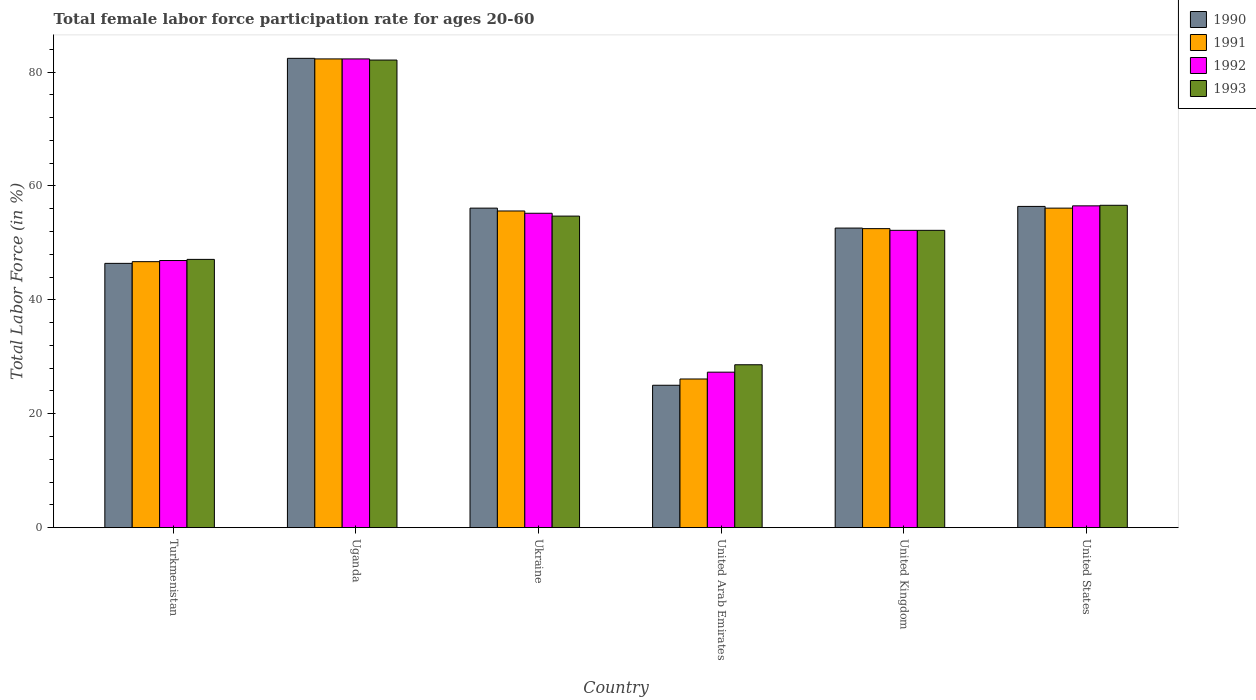How many groups of bars are there?
Give a very brief answer. 6. How many bars are there on the 3rd tick from the left?
Keep it short and to the point. 4. What is the label of the 1st group of bars from the left?
Provide a succinct answer. Turkmenistan. In how many cases, is the number of bars for a given country not equal to the number of legend labels?
Provide a succinct answer. 0. What is the female labor force participation rate in 1990 in Turkmenistan?
Ensure brevity in your answer.  46.4. Across all countries, what is the maximum female labor force participation rate in 1991?
Make the answer very short. 82.3. Across all countries, what is the minimum female labor force participation rate in 1991?
Make the answer very short. 26.1. In which country was the female labor force participation rate in 1992 maximum?
Your response must be concise. Uganda. In which country was the female labor force participation rate in 1992 minimum?
Your answer should be very brief. United Arab Emirates. What is the total female labor force participation rate in 1993 in the graph?
Make the answer very short. 321.3. What is the difference between the female labor force participation rate in 1991 in Ukraine and that in United Kingdom?
Your answer should be compact. 3.1. What is the difference between the female labor force participation rate in 1990 in United Kingdom and the female labor force participation rate in 1991 in United Arab Emirates?
Your answer should be compact. 26.5. What is the average female labor force participation rate in 1993 per country?
Make the answer very short. 53.55. What is the difference between the female labor force participation rate of/in 1991 and female labor force participation rate of/in 1992 in United States?
Provide a succinct answer. -0.4. In how many countries, is the female labor force participation rate in 1990 greater than 56 %?
Make the answer very short. 3. What is the ratio of the female labor force participation rate in 1992 in Ukraine to that in United Arab Emirates?
Offer a very short reply. 2.02. Is the female labor force participation rate in 1990 in United Kingdom less than that in United States?
Ensure brevity in your answer.  Yes. What is the difference between the highest and the second highest female labor force participation rate in 1992?
Offer a terse response. -25.8. What is the difference between the highest and the lowest female labor force participation rate in 1990?
Keep it short and to the point. 57.4. Is the sum of the female labor force participation rate in 1990 in Ukraine and United States greater than the maximum female labor force participation rate in 1991 across all countries?
Provide a succinct answer. Yes. Is it the case that in every country, the sum of the female labor force participation rate in 1990 and female labor force participation rate in 1993 is greater than the sum of female labor force participation rate in 1991 and female labor force participation rate in 1992?
Your response must be concise. No. What is the title of the graph?
Make the answer very short. Total female labor force participation rate for ages 20-60. Does "1973" appear as one of the legend labels in the graph?
Your answer should be compact. No. What is the label or title of the X-axis?
Your answer should be compact. Country. What is the Total Labor Force (in %) of 1990 in Turkmenistan?
Your response must be concise. 46.4. What is the Total Labor Force (in %) of 1991 in Turkmenistan?
Your response must be concise. 46.7. What is the Total Labor Force (in %) of 1992 in Turkmenistan?
Give a very brief answer. 46.9. What is the Total Labor Force (in %) in 1993 in Turkmenistan?
Your response must be concise. 47.1. What is the Total Labor Force (in %) of 1990 in Uganda?
Make the answer very short. 82.4. What is the Total Labor Force (in %) of 1991 in Uganda?
Make the answer very short. 82.3. What is the Total Labor Force (in %) in 1992 in Uganda?
Your response must be concise. 82.3. What is the Total Labor Force (in %) in 1993 in Uganda?
Your answer should be compact. 82.1. What is the Total Labor Force (in %) in 1990 in Ukraine?
Make the answer very short. 56.1. What is the Total Labor Force (in %) in 1991 in Ukraine?
Keep it short and to the point. 55.6. What is the Total Labor Force (in %) in 1992 in Ukraine?
Offer a terse response. 55.2. What is the Total Labor Force (in %) of 1993 in Ukraine?
Ensure brevity in your answer.  54.7. What is the Total Labor Force (in %) in 1991 in United Arab Emirates?
Ensure brevity in your answer.  26.1. What is the Total Labor Force (in %) of 1992 in United Arab Emirates?
Ensure brevity in your answer.  27.3. What is the Total Labor Force (in %) in 1993 in United Arab Emirates?
Provide a short and direct response. 28.6. What is the Total Labor Force (in %) in 1990 in United Kingdom?
Your response must be concise. 52.6. What is the Total Labor Force (in %) of 1991 in United Kingdom?
Ensure brevity in your answer.  52.5. What is the Total Labor Force (in %) in 1992 in United Kingdom?
Make the answer very short. 52.2. What is the Total Labor Force (in %) in 1993 in United Kingdom?
Provide a short and direct response. 52.2. What is the Total Labor Force (in %) of 1990 in United States?
Offer a terse response. 56.4. What is the Total Labor Force (in %) in 1991 in United States?
Provide a succinct answer. 56.1. What is the Total Labor Force (in %) of 1992 in United States?
Your answer should be very brief. 56.5. What is the Total Labor Force (in %) of 1993 in United States?
Ensure brevity in your answer.  56.6. Across all countries, what is the maximum Total Labor Force (in %) of 1990?
Provide a short and direct response. 82.4. Across all countries, what is the maximum Total Labor Force (in %) in 1991?
Ensure brevity in your answer.  82.3. Across all countries, what is the maximum Total Labor Force (in %) of 1992?
Provide a succinct answer. 82.3. Across all countries, what is the maximum Total Labor Force (in %) in 1993?
Provide a short and direct response. 82.1. Across all countries, what is the minimum Total Labor Force (in %) in 1990?
Your answer should be compact. 25. Across all countries, what is the minimum Total Labor Force (in %) in 1991?
Offer a terse response. 26.1. Across all countries, what is the minimum Total Labor Force (in %) in 1992?
Your response must be concise. 27.3. Across all countries, what is the minimum Total Labor Force (in %) of 1993?
Ensure brevity in your answer.  28.6. What is the total Total Labor Force (in %) of 1990 in the graph?
Offer a very short reply. 318.9. What is the total Total Labor Force (in %) in 1991 in the graph?
Your answer should be compact. 319.3. What is the total Total Labor Force (in %) of 1992 in the graph?
Keep it short and to the point. 320.4. What is the total Total Labor Force (in %) of 1993 in the graph?
Your answer should be compact. 321.3. What is the difference between the Total Labor Force (in %) in 1990 in Turkmenistan and that in Uganda?
Offer a terse response. -36. What is the difference between the Total Labor Force (in %) in 1991 in Turkmenistan and that in Uganda?
Your answer should be very brief. -35.6. What is the difference between the Total Labor Force (in %) in 1992 in Turkmenistan and that in Uganda?
Keep it short and to the point. -35.4. What is the difference between the Total Labor Force (in %) in 1993 in Turkmenistan and that in Uganda?
Ensure brevity in your answer.  -35. What is the difference between the Total Labor Force (in %) of 1991 in Turkmenistan and that in Ukraine?
Provide a succinct answer. -8.9. What is the difference between the Total Labor Force (in %) of 1993 in Turkmenistan and that in Ukraine?
Provide a short and direct response. -7.6. What is the difference between the Total Labor Force (in %) in 1990 in Turkmenistan and that in United Arab Emirates?
Offer a very short reply. 21.4. What is the difference between the Total Labor Force (in %) of 1991 in Turkmenistan and that in United Arab Emirates?
Keep it short and to the point. 20.6. What is the difference between the Total Labor Force (in %) in 1992 in Turkmenistan and that in United Arab Emirates?
Provide a succinct answer. 19.6. What is the difference between the Total Labor Force (in %) in 1993 in Turkmenistan and that in United Arab Emirates?
Your answer should be very brief. 18.5. What is the difference between the Total Labor Force (in %) of 1990 in Turkmenistan and that in United Kingdom?
Make the answer very short. -6.2. What is the difference between the Total Labor Force (in %) in 1991 in Turkmenistan and that in United Kingdom?
Your answer should be very brief. -5.8. What is the difference between the Total Labor Force (in %) of 1992 in Turkmenistan and that in United Kingdom?
Offer a very short reply. -5.3. What is the difference between the Total Labor Force (in %) in 1993 in Turkmenistan and that in United Kingdom?
Keep it short and to the point. -5.1. What is the difference between the Total Labor Force (in %) in 1991 in Turkmenistan and that in United States?
Provide a short and direct response. -9.4. What is the difference between the Total Labor Force (in %) in 1990 in Uganda and that in Ukraine?
Your answer should be compact. 26.3. What is the difference between the Total Labor Force (in %) of 1991 in Uganda and that in Ukraine?
Your response must be concise. 26.7. What is the difference between the Total Labor Force (in %) in 1992 in Uganda and that in Ukraine?
Provide a short and direct response. 27.1. What is the difference between the Total Labor Force (in %) in 1993 in Uganda and that in Ukraine?
Offer a terse response. 27.4. What is the difference between the Total Labor Force (in %) of 1990 in Uganda and that in United Arab Emirates?
Keep it short and to the point. 57.4. What is the difference between the Total Labor Force (in %) in 1991 in Uganda and that in United Arab Emirates?
Provide a succinct answer. 56.2. What is the difference between the Total Labor Force (in %) in 1992 in Uganda and that in United Arab Emirates?
Your answer should be compact. 55. What is the difference between the Total Labor Force (in %) in 1993 in Uganda and that in United Arab Emirates?
Offer a very short reply. 53.5. What is the difference between the Total Labor Force (in %) of 1990 in Uganda and that in United Kingdom?
Keep it short and to the point. 29.8. What is the difference between the Total Labor Force (in %) in 1991 in Uganda and that in United Kingdom?
Ensure brevity in your answer.  29.8. What is the difference between the Total Labor Force (in %) in 1992 in Uganda and that in United Kingdom?
Make the answer very short. 30.1. What is the difference between the Total Labor Force (in %) of 1993 in Uganda and that in United Kingdom?
Give a very brief answer. 29.9. What is the difference between the Total Labor Force (in %) in 1991 in Uganda and that in United States?
Offer a terse response. 26.2. What is the difference between the Total Labor Force (in %) of 1992 in Uganda and that in United States?
Make the answer very short. 25.8. What is the difference between the Total Labor Force (in %) in 1990 in Ukraine and that in United Arab Emirates?
Offer a terse response. 31.1. What is the difference between the Total Labor Force (in %) in 1991 in Ukraine and that in United Arab Emirates?
Your response must be concise. 29.5. What is the difference between the Total Labor Force (in %) in 1992 in Ukraine and that in United Arab Emirates?
Provide a succinct answer. 27.9. What is the difference between the Total Labor Force (in %) of 1993 in Ukraine and that in United Arab Emirates?
Offer a terse response. 26.1. What is the difference between the Total Labor Force (in %) in 1990 in Ukraine and that in United Kingdom?
Make the answer very short. 3.5. What is the difference between the Total Labor Force (in %) in 1991 in Ukraine and that in United Kingdom?
Offer a very short reply. 3.1. What is the difference between the Total Labor Force (in %) in 1992 in Ukraine and that in United Kingdom?
Give a very brief answer. 3. What is the difference between the Total Labor Force (in %) of 1992 in Ukraine and that in United States?
Offer a very short reply. -1.3. What is the difference between the Total Labor Force (in %) in 1993 in Ukraine and that in United States?
Keep it short and to the point. -1.9. What is the difference between the Total Labor Force (in %) in 1990 in United Arab Emirates and that in United Kingdom?
Provide a succinct answer. -27.6. What is the difference between the Total Labor Force (in %) of 1991 in United Arab Emirates and that in United Kingdom?
Your response must be concise. -26.4. What is the difference between the Total Labor Force (in %) of 1992 in United Arab Emirates and that in United Kingdom?
Give a very brief answer. -24.9. What is the difference between the Total Labor Force (in %) of 1993 in United Arab Emirates and that in United Kingdom?
Offer a very short reply. -23.6. What is the difference between the Total Labor Force (in %) of 1990 in United Arab Emirates and that in United States?
Offer a terse response. -31.4. What is the difference between the Total Labor Force (in %) in 1991 in United Arab Emirates and that in United States?
Offer a very short reply. -30. What is the difference between the Total Labor Force (in %) in 1992 in United Arab Emirates and that in United States?
Provide a short and direct response. -29.2. What is the difference between the Total Labor Force (in %) of 1990 in United Kingdom and that in United States?
Provide a short and direct response. -3.8. What is the difference between the Total Labor Force (in %) in 1992 in United Kingdom and that in United States?
Your response must be concise. -4.3. What is the difference between the Total Labor Force (in %) of 1993 in United Kingdom and that in United States?
Make the answer very short. -4.4. What is the difference between the Total Labor Force (in %) in 1990 in Turkmenistan and the Total Labor Force (in %) in 1991 in Uganda?
Provide a succinct answer. -35.9. What is the difference between the Total Labor Force (in %) in 1990 in Turkmenistan and the Total Labor Force (in %) in 1992 in Uganda?
Your answer should be very brief. -35.9. What is the difference between the Total Labor Force (in %) of 1990 in Turkmenistan and the Total Labor Force (in %) of 1993 in Uganda?
Your answer should be very brief. -35.7. What is the difference between the Total Labor Force (in %) in 1991 in Turkmenistan and the Total Labor Force (in %) in 1992 in Uganda?
Offer a terse response. -35.6. What is the difference between the Total Labor Force (in %) of 1991 in Turkmenistan and the Total Labor Force (in %) of 1993 in Uganda?
Ensure brevity in your answer.  -35.4. What is the difference between the Total Labor Force (in %) of 1992 in Turkmenistan and the Total Labor Force (in %) of 1993 in Uganda?
Offer a very short reply. -35.2. What is the difference between the Total Labor Force (in %) in 1990 in Turkmenistan and the Total Labor Force (in %) in 1991 in Ukraine?
Your response must be concise. -9.2. What is the difference between the Total Labor Force (in %) in 1990 in Turkmenistan and the Total Labor Force (in %) in 1993 in Ukraine?
Provide a short and direct response. -8.3. What is the difference between the Total Labor Force (in %) of 1991 in Turkmenistan and the Total Labor Force (in %) of 1992 in Ukraine?
Your response must be concise. -8.5. What is the difference between the Total Labor Force (in %) in 1991 in Turkmenistan and the Total Labor Force (in %) in 1993 in Ukraine?
Provide a short and direct response. -8. What is the difference between the Total Labor Force (in %) of 1992 in Turkmenistan and the Total Labor Force (in %) of 1993 in Ukraine?
Provide a succinct answer. -7.8. What is the difference between the Total Labor Force (in %) in 1990 in Turkmenistan and the Total Labor Force (in %) in 1991 in United Arab Emirates?
Make the answer very short. 20.3. What is the difference between the Total Labor Force (in %) in 1990 in Turkmenistan and the Total Labor Force (in %) in 1992 in United Arab Emirates?
Ensure brevity in your answer.  19.1. What is the difference between the Total Labor Force (in %) of 1992 in Turkmenistan and the Total Labor Force (in %) of 1993 in United Arab Emirates?
Ensure brevity in your answer.  18.3. What is the difference between the Total Labor Force (in %) in 1990 in Turkmenistan and the Total Labor Force (in %) in 1993 in United Kingdom?
Give a very brief answer. -5.8. What is the difference between the Total Labor Force (in %) in 1991 in Turkmenistan and the Total Labor Force (in %) in 1992 in United Kingdom?
Offer a very short reply. -5.5. What is the difference between the Total Labor Force (in %) in 1990 in Turkmenistan and the Total Labor Force (in %) in 1991 in United States?
Provide a succinct answer. -9.7. What is the difference between the Total Labor Force (in %) in 1990 in Turkmenistan and the Total Labor Force (in %) in 1992 in United States?
Ensure brevity in your answer.  -10.1. What is the difference between the Total Labor Force (in %) of 1990 in Turkmenistan and the Total Labor Force (in %) of 1993 in United States?
Ensure brevity in your answer.  -10.2. What is the difference between the Total Labor Force (in %) of 1991 in Turkmenistan and the Total Labor Force (in %) of 1992 in United States?
Offer a terse response. -9.8. What is the difference between the Total Labor Force (in %) of 1991 in Turkmenistan and the Total Labor Force (in %) of 1993 in United States?
Provide a short and direct response. -9.9. What is the difference between the Total Labor Force (in %) in 1992 in Turkmenistan and the Total Labor Force (in %) in 1993 in United States?
Your answer should be very brief. -9.7. What is the difference between the Total Labor Force (in %) in 1990 in Uganda and the Total Labor Force (in %) in 1991 in Ukraine?
Give a very brief answer. 26.8. What is the difference between the Total Labor Force (in %) of 1990 in Uganda and the Total Labor Force (in %) of 1992 in Ukraine?
Your answer should be compact. 27.2. What is the difference between the Total Labor Force (in %) of 1990 in Uganda and the Total Labor Force (in %) of 1993 in Ukraine?
Offer a terse response. 27.7. What is the difference between the Total Labor Force (in %) in 1991 in Uganda and the Total Labor Force (in %) in 1992 in Ukraine?
Ensure brevity in your answer.  27.1. What is the difference between the Total Labor Force (in %) of 1991 in Uganda and the Total Labor Force (in %) of 1993 in Ukraine?
Your answer should be very brief. 27.6. What is the difference between the Total Labor Force (in %) in 1992 in Uganda and the Total Labor Force (in %) in 1993 in Ukraine?
Keep it short and to the point. 27.6. What is the difference between the Total Labor Force (in %) of 1990 in Uganda and the Total Labor Force (in %) of 1991 in United Arab Emirates?
Provide a short and direct response. 56.3. What is the difference between the Total Labor Force (in %) of 1990 in Uganda and the Total Labor Force (in %) of 1992 in United Arab Emirates?
Provide a succinct answer. 55.1. What is the difference between the Total Labor Force (in %) in 1990 in Uganda and the Total Labor Force (in %) in 1993 in United Arab Emirates?
Make the answer very short. 53.8. What is the difference between the Total Labor Force (in %) in 1991 in Uganda and the Total Labor Force (in %) in 1992 in United Arab Emirates?
Ensure brevity in your answer.  55. What is the difference between the Total Labor Force (in %) in 1991 in Uganda and the Total Labor Force (in %) in 1993 in United Arab Emirates?
Offer a very short reply. 53.7. What is the difference between the Total Labor Force (in %) in 1992 in Uganda and the Total Labor Force (in %) in 1993 in United Arab Emirates?
Make the answer very short. 53.7. What is the difference between the Total Labor Force (in %) of 1990 in Uganda and the Total Labor Force (in %) of 1991 in United Kingdom?
Offer a very short reply. 29.9. What is the difference between the Total Labor Force (in %) of 1990 in Uganda and the Total Labor Force (in %) of 1992 in United Kingdom?
Your response must be concise. 30.2. What is the difference between the Total Labor Force (in %) in 1990 in Uganda and the Total Labor Force (in %) in 1993 in United Kingdom?
Your response must be concise. 30.2. What is the difference between the Total Labor Force (in %) of 1991 in Uganda and the Total Labor Force (in %) of 1992 in United Kingdom?
Offer a very short reply. 30.1. What is the difference between the Total Labor Force (in %) of 1991 in Uganda and the Total Labor Force (in %) of 1993 in United Kingdom?
Keep it short and to the point. 30.1. What is the difference between the Total Labor Force (in %) of 1992 in Uganda and the Total Labor Force (in %) of 1993 in United Kingdom?
Your response must be concise. 30.1. What is the difference between the Total Labor Force (in %) in 1990 in Uganda and the Total Labor Force (in %) in 1991 in United States?
Your response must be concise. 26.3. What is the difference between the Total Labor Force (in %) in 1990 in Uganda and the Total Labor Force (in %) in 1992 in United States?
Offer a very short reply. 25.9. What is the difference between the Total Labor Force (in %) in 1990 in Uganda and the Total Labor Force (in %) in 1993 in United States?
Make the answer very short. 25.8. What is the difference between the Total Labor Force (in %) in 1991 in Uganda and the Total Labor Force (in %) in 1992 in United States?
Provide a short and direct response. 25.8. What is the difference between the Total Labor Force (in %) of 1991 in Uganda and the Total Labor Force (in %) of 1993 in United States?
Your response must be concise. 25.7. What is the difference between the Total Labor Force (in %) in 1992 in Uganda and the Total Labor Force (in %) in 1993 in United States?
Make the answer very short. 25.7. What is the difference between the Total Labor Force (in %) of 1990 in Ukraine and the Total Labor Force (in %) of 1992 in United Arab Emirates?
Your response must be concise. 28.8. What is the difference between the Total Labor Force (in %) in 1990 in Ukraine and the Total Labor Force (in %) in 1993 in United Arab Emirates?
Ensure brevity in your answer.  27.5. What is the difference between the Total Labor Force (in %) in 1991 in Ukraine and the Total Labor Force (in %) in 1992 in United Arab Emirates?
Your response must be concise. 28.3. What is the difference between the Total Labor Force (in %) in 1992 in Ukraine and the Total Labor Force (in %) in 1993 in United Arab Emirates?
Your response must be concise. 26.6. What is the difference between the Total Labor Force (in %) of 1991 in Ukraine and the Total Labor Force (in %) of 1993 in United Kingdom?
Provide a succinct answer. 3.4. What is the difference between the Total Labor Force (in %) of 1992 in Ukraine and the Total Labor Force (in %) of 1993 in United Kingdom?
Make the answer very short. 3. What is the difference between the Total Labor Force (in %) of 1990 in Ukraine and the Total Labor Force (in %) of 1991 in United States?
Offer a very short reply. 0. What is the difference between the Total Labor Force (in %) in 1990 in Ukraine and the Total Labor Force (in %) in 1993 in United States?
Keep it short and to the point. -0.5. What is the difference between the Total Labor Force (in %) of 1991 in Ukraine and the Total Labor Force (in %) of 1992 in United States?
Give a very brief answer. -0.9. What is the difference between the Total Labor Force (in %) of 1990 in United Arab Emirates and the Total Labor Force (in %) of 1991 in United Kingdom?
Keep it short and to the point. -27.5. What is the difference between the Total Labor Force (in %) of 1990 in United Arab Emirates and the Total Labor Force (in %) of 1992 in United Kingdom?
Offer a terse response. -27.2. What is the difference between the Total Labor Force (in %) in 1990 in United Arab Emirates and the Total Labor Force (in %) in 1993 in United Kingdom?
Your response must be concise. -27.2. What is the difference between the Total Labor Force (in %) in 1991 in United Arab Emirates and the Total Labor Force (in %) in 1992 in United Kingdom?
Your answer should be very brief. -26.1. What is the difference between the Total Labor Force (in %) in 1991 in United Arab Emirates and the Total Labor Force (in %) in 1993 in United Kingdom?
Make the answer very short. -26.1. What is the difference between the Total Labor Force (in %) of 1992 in United Arab Emirates and the Total Labor Force (in %) of 1993 in United Kingdom?
Offer a very short reply. -24.9. What is the difference between the Total Labor Force (in %) in 1990 in United Arab Emirates and the Total Labor Force (in %) in 1991 in United States?
Make the answer very short. -31.1. What is the difference between the Total Labor Force (in %) in 1990 in United Arab Emirates and the Total Labor Force (in %) in 1992 in United States?
Provide a short and direct response. -31.5. What is the difference between the Total Labor Force (in %) in 1990 in United Arab Emirates and the Total Labor Force (in %) in 1993 in United States?
Ensure brevity in your answer.  -31.6. What is the difference between the Total Labor Force (in %) in 1991 in United Arab Emirates and the Total Labor Force (in %) in 1992 in United States?
Your answer should be compact. -30.4. What is the difference between the Total Labor Force (in %) of 1991 in United Arab Emirates and the Total Labor Force (in %) of 1993 in United States?
Your answer should be very brief. -30.5. What is the difference between the Total Labor Force (in %) in 1992 in United Arab Emirates and the Total Labor Force (in %) in 1993 in United States?
Make the answer very short. -29.3. What is the difference between the Total Labor Force (in %) in 1990 in United Kingdom and the Total Labor Force (in %) in 1991 in United States?
Provide a succinct answer. -3.5. What is the average Total Labor Force (in %) in 1990 per country?
Offer a very short reply. 53.15. What is the average Total Labor Force (in %) in 1991 per country?
Your answer should be very brief. 53.22. What is the average Total Labor Force (in %) of 1992 per country?
Provide a succinct answer. 53.4. What is the average Total Labor Force (in %) of 1993 per country?
Your answer should be very brief. 53.55. What is the difference between the Total Labor Force (in %) of 1990 and Total Labor Force (in %) of 1993 in Turkmenistan?
Keep it short and to the point. -0.7. What is the difference between the Total Labor Force (in %) in 1991 and Total Labor Force (in %) in 1992 in Turkmenistan?
Ensure brevity in your answer.  -0.2. What is the difference between the Total Labor Force (in %) of 1990 and Total Labor Force (in %) of 1991 in Uganda?
Provide a succinct answer. 0.1. What is the difference between the Total Labor Force (in %) of 1990 and Total Labor Force (in %) of 1992 in Uganda?
Offer a terse response. 0.1. What is the difference between the Total Labor Force (in %) of 1990 and Total Labor Force (in %) of 1993 in Uganda?
Provide a short and direct response. 0.3. What is the difference between the Total Labor Force (in %) in 1991 and Total Labor Force (in %) in 1992 in Uganda?
Provide a succinct answer. 0. What is the difference between the Total Labor Force (in %) of 1990 and Total Labor Force (in %) of 1991 in Ukraine?
Offer a very short reply. 0.5. What is the difference between the Total Labor Force (in %) of 1990 and Total Labor Force (in %) of 1992 in Ukraine?
Ensure brevity in your answer.  0.9. What is the difference between the Total Labor Force (in %) of 1990 and Total Labor Force (in %) of 1993 in Ukraine?
Offer a terse response. 1.4. What is the difference between the Total Labor Force (in %) of 1991 and Total Labor Force (in %) of 1992 in Ukraine?
Keep it short and to the point. 0.4. What is the difference between the Total Labor Force (in %) of 1990 and Total Labor Force (in %) of 1991 in United Arab Emirates?
Give a very brief answer. -1.1. What is the difference between the Total Labor Force (in %) of 1990 and Total Labor Force (in %) of 1993 in United Arab Emirates?
Offer a terse response. -3.6. What is the difference between the Total Labor Force (in %) of 1991 and Total Labor Force (in %) of 1992 in United Arab Emirates?
Offer a very short reply. -1.2. What is the difference between the Total Labor Force (in %) in 1992 and Total Labor Force (in %) in 1993 in United Arab Emirates?
Offer a terse response. -1.3. What is the difference between the Total Labor Force (in %) in 1990 and Total Labor Force (in %) in 1992 in United Kingdom?
Offer a very short reply. 0.4. What is the difference between the Total Labor Force (in %) in 1990 and Total Labor Force (in %) in 1992 in United States?
Provide a succinct answer. -0.1. What is the difference between the Total Labor Force (in %) in 1991 and Total Labor Force (in %) in 1993 in United States?
Keep it short and to the point. -0.5. What is the difference between the Total Labor Force (in %) in 1992 and Total Labor Force (in %) in 1993 in United States?
Your answer should be very brief. -0.1. What is the ratio of the Total Labor Force (in %) in 1990 in Turkmenistan to that in Uganda?
Provide a short and direct response. 0.56. What is the ratio of the Total Labor Force (in %) of 1991 in Turkmenistan to that in Uganda?
Make the answer very short. 0.57. What is the ratio of the Total Labor Force (in %) of 1992 in Turkmenistan to that in Uganda?
Provide a short and direct response. 0.57. What is the ratio of the Total Labor Force (in %) of 1993 in Turkmenistan to that in Uganda?
Offer a very short reply. 0.57. What is the ratio of the Total Labor Force (in %) of 1990 in Turkmenistan to that in Ukraine?
Offer a terse response. 0.83. What is the ratio of the Total Labor Force (in %) in 1991 in Turkmenistan to that in Ukraine?
Provide a short and direct response. 0.84. What is the ratio of the Total Labor Force (in %) of 1992 in Turkmenistan to that in Ukraine?
Provide a short and direct response. 0.85. What is the ratio of the Total Labor Force (in %) of 1993 in Turkmenistan to that in Ukraine?
Your response must be concise. 0.86. What is the ratio of the Total Labor Force (in %) in 1990 in Turkmenistan to that in United Arab Emirates?
Make the answer very short. 1.86. What is the ratio of the Total Labor Force (in %) of 1991 in Turkmenistan to that in United Arab Emirates?
Provide a short and direct response. 1.79. What is the ratio of the Total Labor Force (in %) in 1992 in Turkmenistan to that in United Arab Emirates?
Make the answer very short. 1.72. What is the ratio of the Total Labor Force (in %) in 1993 in Turkmenistan to that in United Arab Emirates?
Give a very brief answer. 1.65. What is the ratio of the Total Labor Force (in %) in 1990 in Turkmenistan to that in United Kingdom?
Your response must be concise. 0.88. What is the ratio of the Total Labor Force (in %) in 1991 in Turkmenistan to that in United Kingdom?
Offer a very short reply. 0.89. What is the ratio of the Total Labor Force (in %) of 1992 in Turkmenistan to that in United Kingdom?
Make the answer very short. 0.9. What is the ratio of the Total Labor Force (in %) of 1993 in Turkmenistan to that in United Kingdom?
Ensure brevity in your answer.  0.9. What is the ratio of the Total Labor Force (in %) of 1990 in Turkmenistan to that in United States?
Ensure brevity in your answer.  0.82. What is the ratio of the Total Labor Force (in %) in 1991 in Turkmenistan to that in United States?
Ensure brevity in your answer.  0.83. What is the ratio of the Total Labor Force (in %) in 1992 in Turkmenistan to that in United States?
Make the answer very short. 0.83. What is the ratio of the Total Labor Force (in %) of 1993 in Turkmenistan to that in United States?
Offer a terse response. 0.83. What is the ratio of the Total Labor Force (in %) of 1990 in Uganda to that in Ukraine?
Your answer should be very brief. 1.47. What is the ratio of the Total Labor Force (in %) in 1991 in Uganda to that in Ukraine?
Keep it short and to the point. 1.48. What is the ratio of the Total Labor Force (in %) of 1992 in Uganda to that in Ukraine?
Your response must be concise. 1.49. What is the ratio of the Total Labor Force (in %) of 1993 in Uganda to that in Ukraine?
Offer a terse response. 1.5. What is the ratio of the Total Labor Force (in %) of 1990 in Uganda to that in United Arab Emirates?
Provide a short and direct response. 3.3. What is the ratio of the Total Labor Force (in %) in 1991 in Uganda to that in United Arab Emirates?
Make the answer very short. 3.15. What is the ratio of the Total Labor Force (in %) in 1992 in Uganda to that in United Arab Emirates?
Ensure brevity in your answer.  3.01. What is the ratio of the Total Labor Force (in %) of 1993 in Uganda to that in United Arab Emirates?
Provide a succinct answer. 2.87. What is the ratio of the Total Labor Force (in %) of 1990 in Uganda to that in United Kingdom?
Give a very brief answer. 1.57. What is the ratio of the Total Labor Force (in %) in 1991 in Uganda to that in United Kingdom?
Give a very brief answer. 1.57. What is the ratio of the Total Labor Force (in %) of 1992 in Uganda to that in United Kingdom?
Keep it short and to the point. 1.58. What is the ratio of the Total Labor Force (in %) in 1993 in Uganda to that in United Kingdom?
Provide a short and direct response. 1.57. What is the ratio of the Total Labor Force (in %) of 1990 in Uganda to that in United States?
Offer a very short reply. 1.46. What is the ratio of the Total Labor Force (in %) in 1991 in Uganda to that in United States?
Provide a succinct answer. 1.47. What is the ratio of the Total Labor Force (in %) in 1992 in Uganda to that in United States?
Keep it short and to the point. 1.46. What is the ratio of the Total Labor Force (in %) in 1993 in Uganda to that in United States?
Your answer should be very brief. 1.45. What is the ratio of the Total Labor Force (in %) in 1990 in Ukraine to that in United Arab Emirates?
Provide a short and direct response. 2.24. What is the ratio of the Total Labor Force (in %) of 1991 in Ukraine to that in United Arab Emirates?
Make the answer very short. 2.13. What is the ratio of the Total Labor Force (in %) of 1992 in Ukraine to that in United Arab Emirates?
Make the answer very short. 2.02. What is the ratio of the Total Labor Force (in %) of 1993 in Ukraine to that in United Arab Emirates?
Your answer should be very brief. 1.91. What is the ratio of the Total Labor Force (in %) of 1990 in Ukraine to that in United Kingdom?
Ensure brevity in your answer.  1.07. What is the ratio of the Total Labor Force (in %) in 1991 in Ukraine to that in United Kingdom?
Offer a terse response. 1.06. What is the ratio of the Total Labor Force (in %) in 1992 in Ukraine to that in United Kingdom?
Keep it short and to the point. 1.06. What is the ratio of the Total Labor Force (in %) of 1993 in Ukraine to that in United Kingdom?
Ensure brevity in your answer.  1.05. What is the ratio of the Total Labor Force (in %) in 1992 in Ukraine to that in United States?
Your answer should be compact. 0.98. What is the ratio of the Total Labor Force (in %) of 1993 in Ukraine to that in United States?
Your response must be concise. 0.97. What is the ratio of the Total Labor Force (in %) in 1990 in United Arab Emirates to that in United Kingdom?
Keep it short and to the point. 0.48. What is the ratio of the Total Labor Force (in %) in 1991 in United Arab Emirates to that in United Kingdom?
Provide a succinct answer. 0.5. What is the ratio of the Total Labor Force (in %) of 1992 in United Arab Emirates to that in United Kingdom?
Offer a very short reply. 0.52. What is the ratio of the Total Labor Force (in %) in 1993 in United Arab Emirates to that in United Kingdom?
Make the answer very short. 0.55. What is the ratio of the Total Labor Force (in %) in 1990 in United Arab Emirates to that in United States?
Your answer should be compact. 0.44. What is the ratio of the Total Labor Force (in %) of 1991 in United Arab Emirates to that in United States?
Provide a short and direct response. 0.47. What is the ratio of the Total Labor Force (in %) in 1992 in United Arab Emirates to that in United States?
Provide a succinct answer. 0.48. What is the ratio of the Total Labor Force (in %) in 1993 in United Arab Emirates to that in United States?
Provide a succinct answer. 0.51. What is the ratio of the Total Labor Force (in %) in 1990 in United Kingdom to that in United States?
Offer a terse response. 0.93. What is the ratio of the Total Labor Force (in %) in 1991 in United Kingdom to that in United States?
Offer a very short reply. 0.94. What is the ratio of the Total Labor Force (in %) of 1992 in United Kingdom to that in United States?
Provide a short and direct response. 0.92. What is the ratio of the Total Labor Force (in %) in 1993 in United Kingdom to that in United States?
Provide a succinct answer. 0.92. What is the difference between the highest and the second highest Total Labor Force (in %) in 1990?
Provide a succinct answer. 26. What is the difference between the highest and the second highest Total Labor Force (in %) in 1991?
Provide a succinct answer. 26.2. What is the difference between the highest and the second highest Total Labor Force (in %) in 1992?
Provide a succinct answer. 25.8. What is the difference between the highest and the lowest Total Labor Force (in %) of 1990?
Offer a very short reply. 57.4. What is the difference between the highest and the lowest Total Labor Force (in %) of 1991?
Your response must be concise. 56.2. What is the difference between the highest and the lowest Total Labor Force (in %) of 1992?
Ensure brevity in your answer.  55. What is the difference between the highest and the lowest Total Labor Force (in %) of 1993?
Your response must be concise. 53.5. 